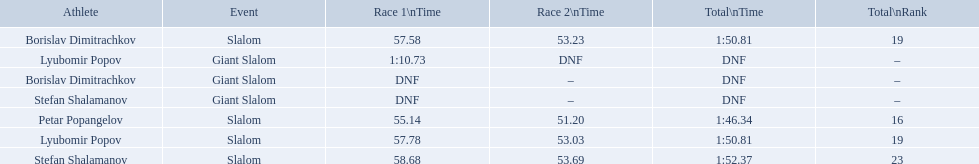Which event is the giant slalom? Giant Slalom, Giant Slalom, Giant Slalom. Which one is lyubomir popov? Lyubomir Popov. What is race 1 tim? 1:10.73. What are all the competitions lyubomir popov competed in? Lyubomir Popov, Lyubomir Popov. Of those, which were giant slalom races? Giant Slalom. What was his time in race 1? 1:10.73. 